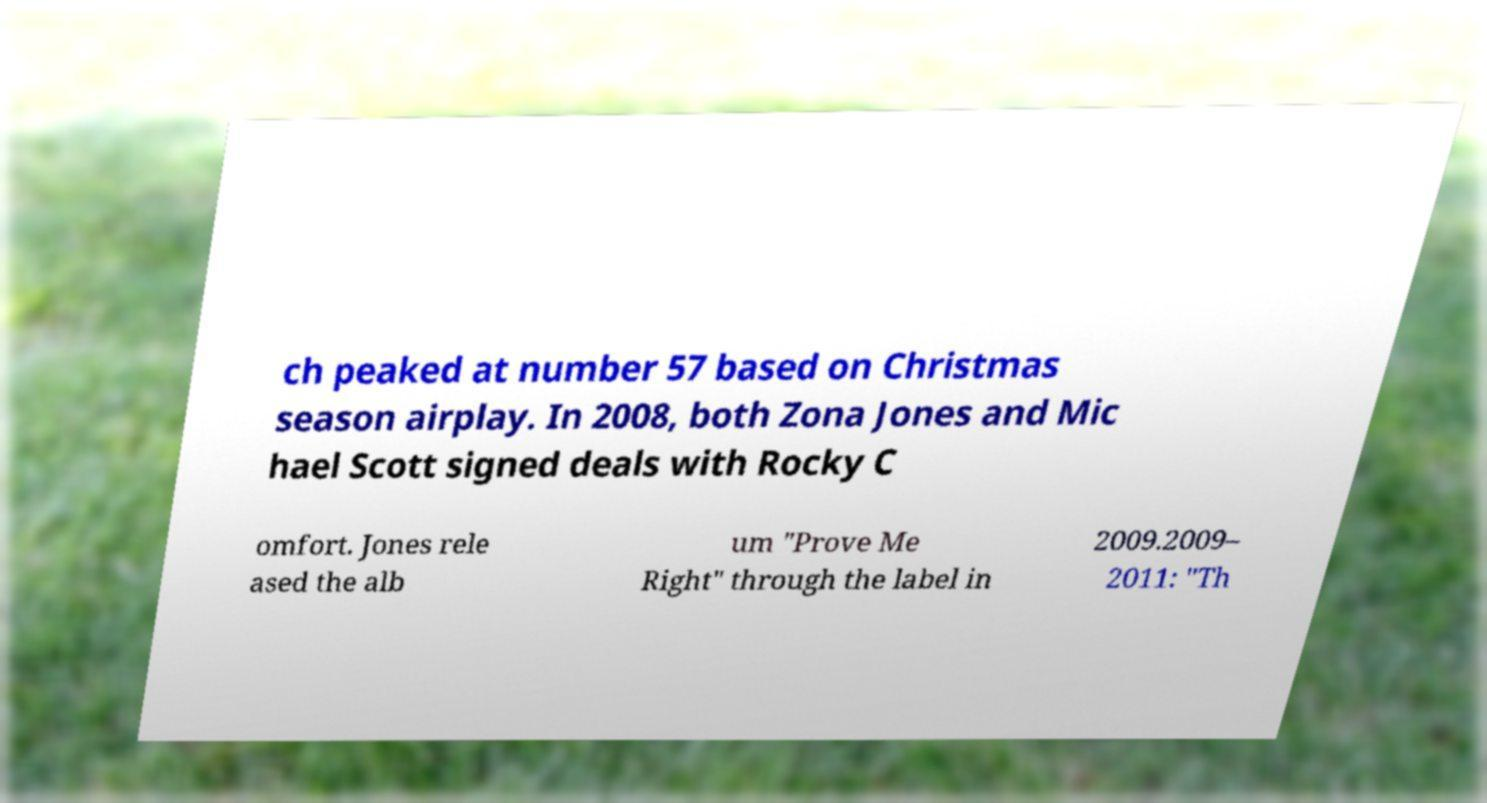Please identify and transcribe the text found in this image. ch peaked at number 57 based on Christmas season airplay. In 2008, both Zona Jones and Mic hael Scott signed deals with Rocky C omfort. Jones rele ased the alb um "Prove Me Right" through the label in 2009.2009– 2011: "Th 